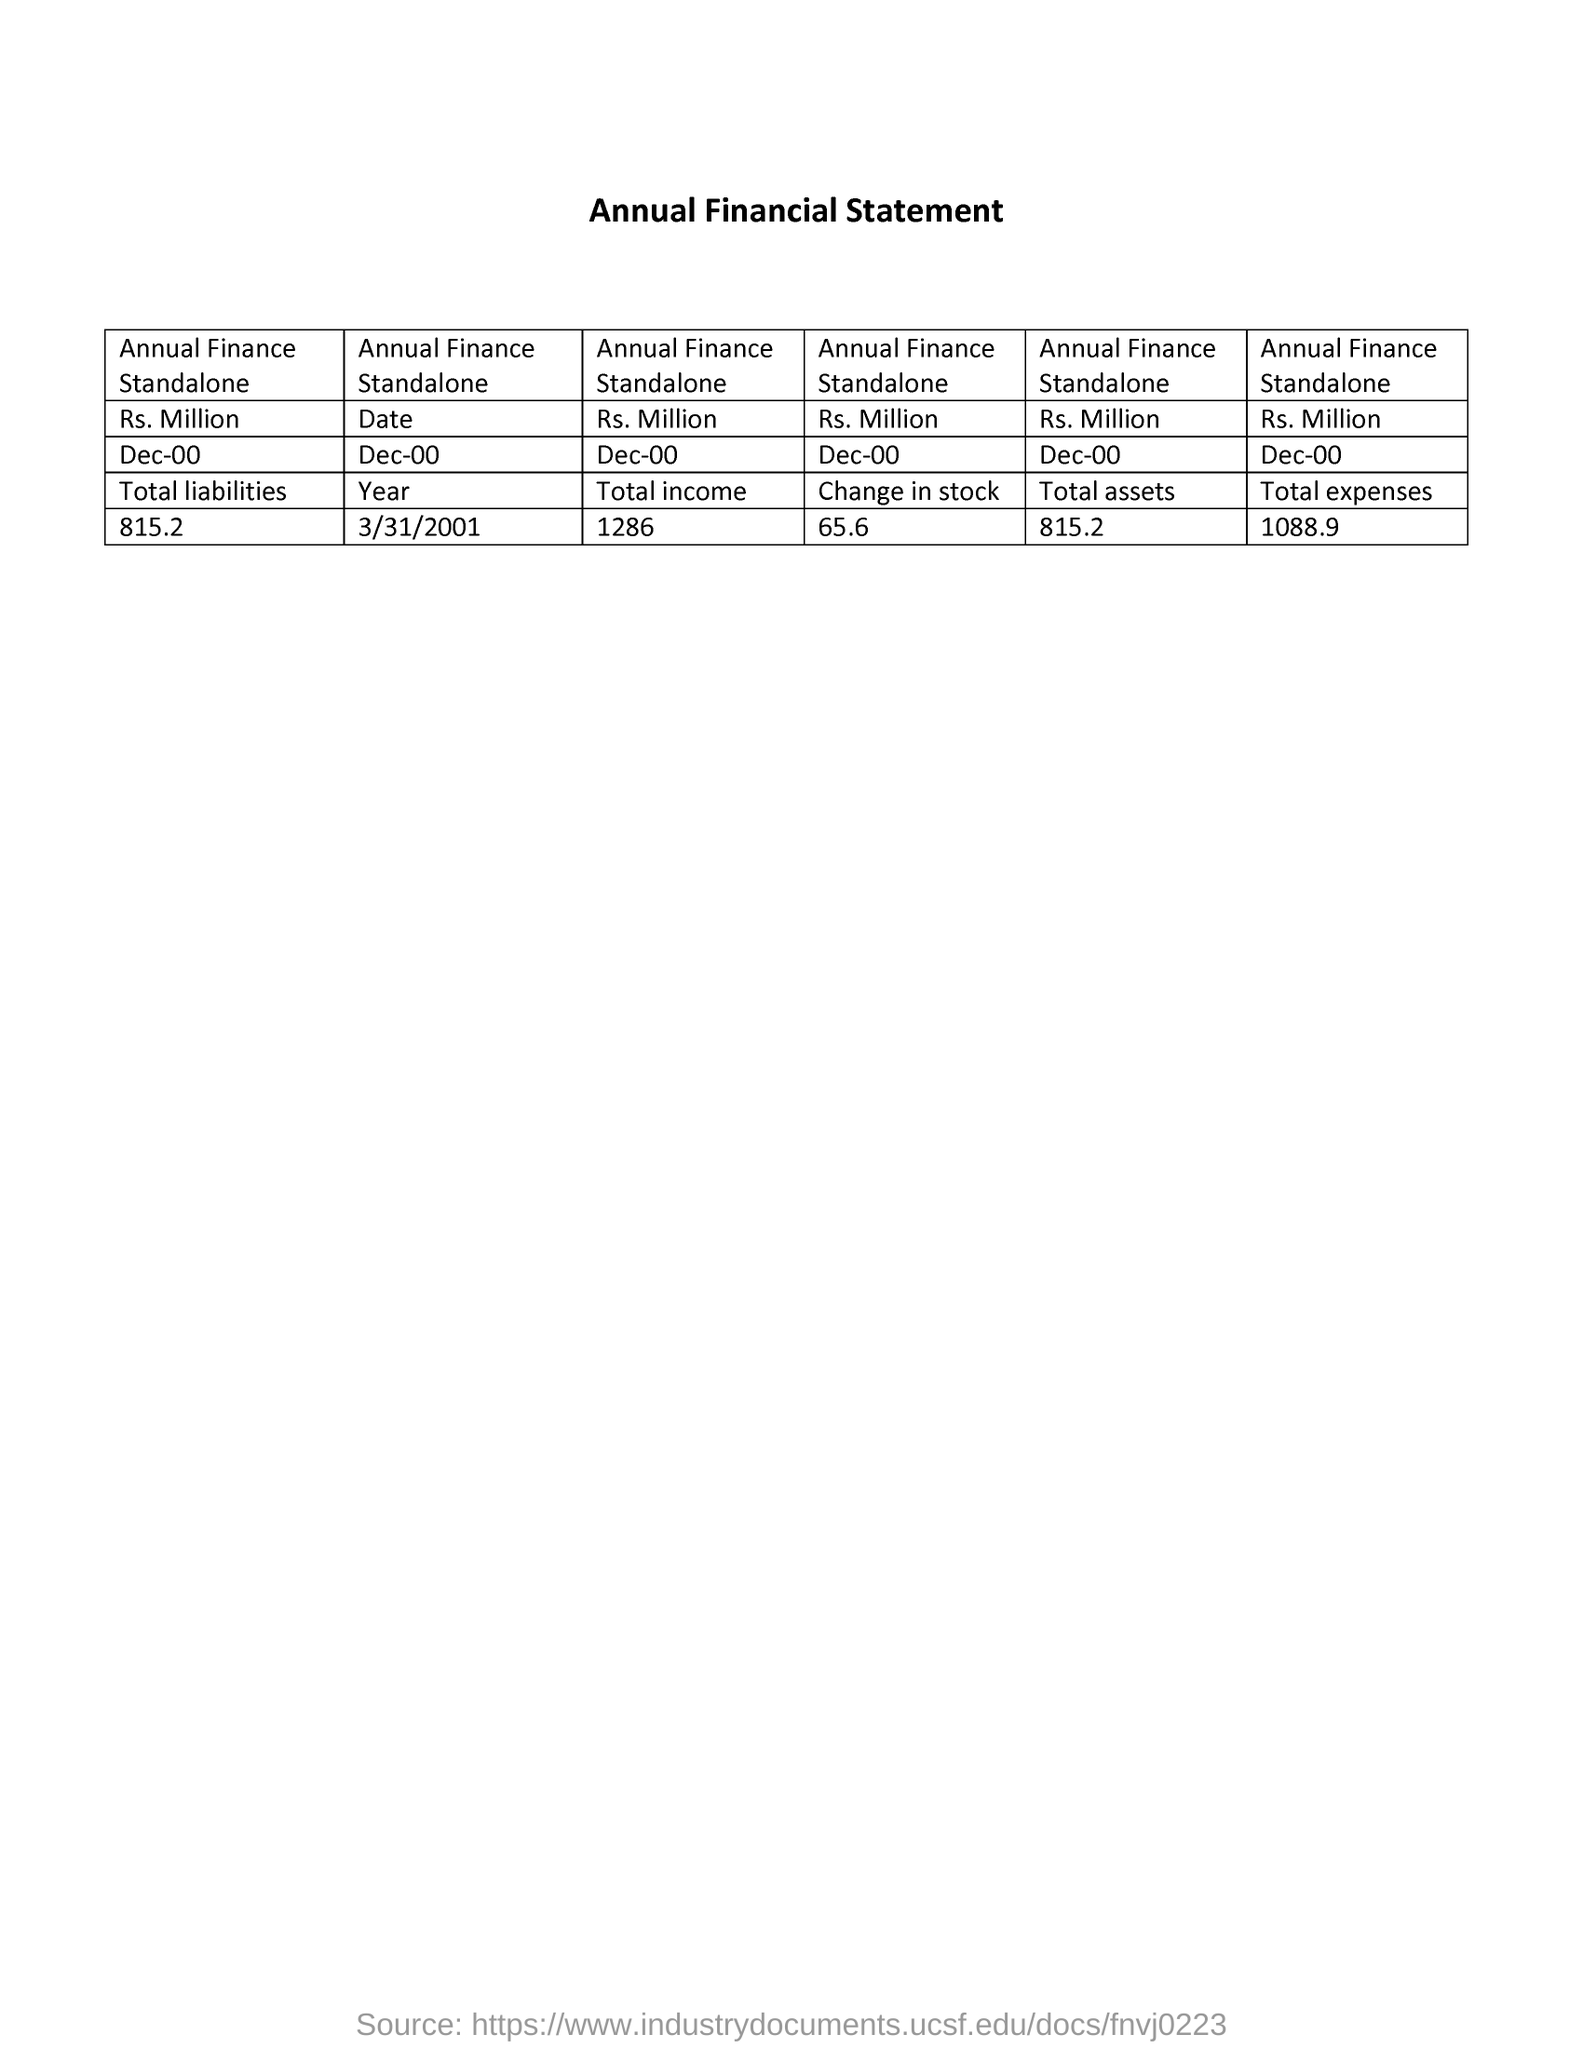Give some essential details in this illustration. The value of the change in stock is 65.6 units. The total expenses given is 1088.9. The value of the currency is denoted in Rupees (RS.) followed by the abbreviation "Million". The value of the "Total assets" for Annual Finance Standalone is 815.2.. The value given for "Total liabilities" is 815.2. 